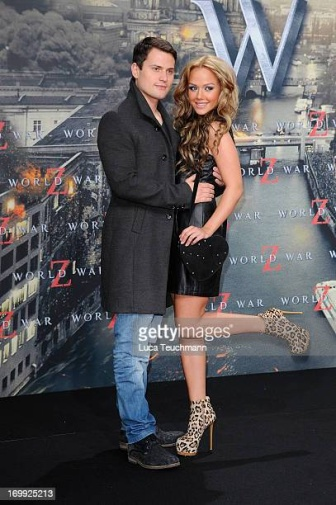Imagine the man and woman are characters in a spy thriller. How might their adventures begin? Their adventures begin on a glamorous night at the premiere of 'World War Z,' where the man, a secret intelligence officer, has been summoned to meet a contact. The woman, who appears to be his date, is actually his partner in espionage, a skilled hacker and martial artist. As the premiere progresses, they receive a cryptic message indicating that a high-stakes conspiracy is about to unfold in the city. What starts as a night of entertainment soon turns into a thrilling pursuit, with the duo racing against time to uncover the masterminds behind the plot. Using their combined skills and unwavering trust in each other, they navigate through a maze of deception, danger, and intrigue, all while maintaining their cover as ordinary event attendees. 